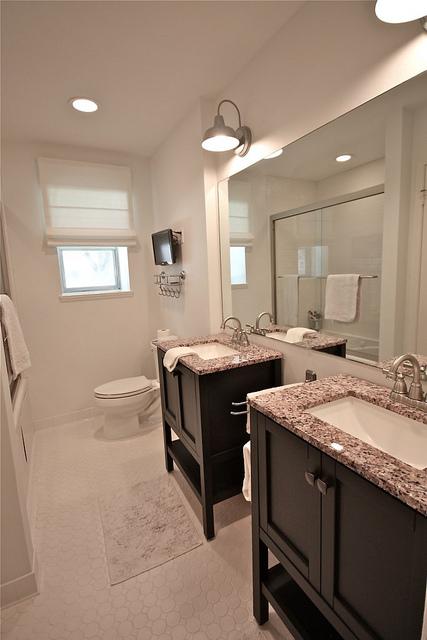What number of towels are in this bathroom?
Short answer required. 2. What type of tile is on the sink?
Concise answer only. Granite. Are there more than two sinks in the bathroom?
Quick response, please. No. Which room is this?
Give a very brief answer. Bathroom. What room of the house is this?
Quick response, please. Bathroom. What room is this?
Answer briefly. Bathroom. 